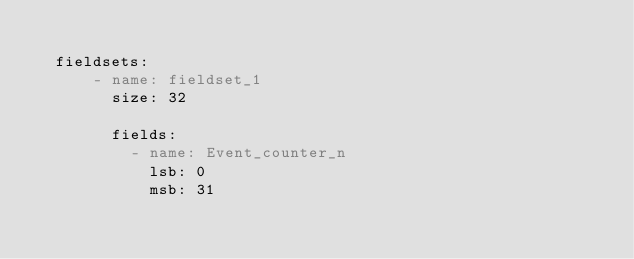Convert code to text. <code><loc_0><loc_0><loc_500><loc_500><_YAML_>
  fieldsets:
      - name: fieldset_1
        size: 32

        fields:
          - name: Event_counter_n
            lsb: 0
            msb: 31
</code> 